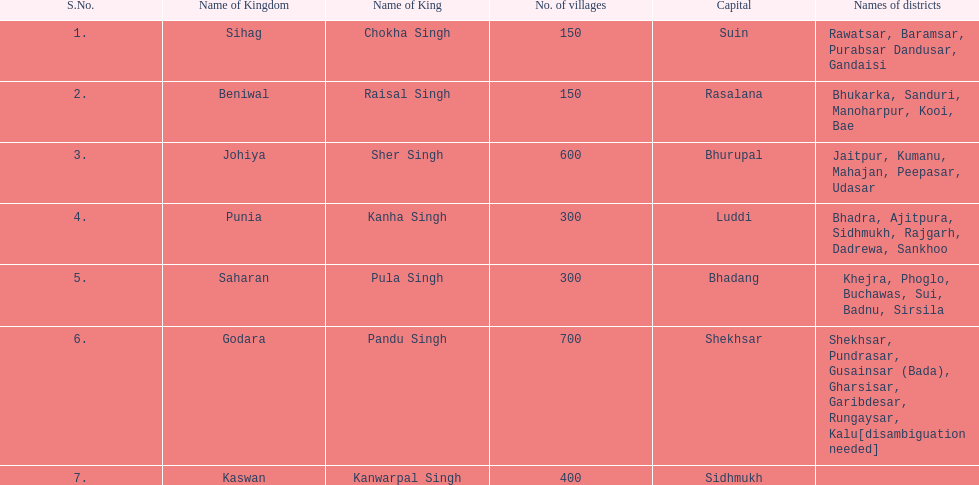What are all the realms? Sihag, Beniwal, Johiya, Punia, Saharan, Godara, Kaswan. How many hamlets do they encompass? 150, 150, 600, 300, 300, 700, 400. How many are in godara? 700. Which realm follows in terms of the largest number of hamlets? Johiya. 